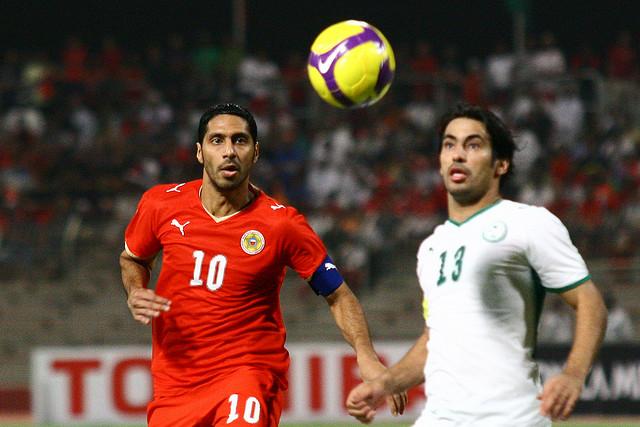What color is player number 10's shirt?
Concise answer only. Red. What are they looking at?
Answer briefly. Ball. Is this a soccer ball?
Be succinct. Yes. 